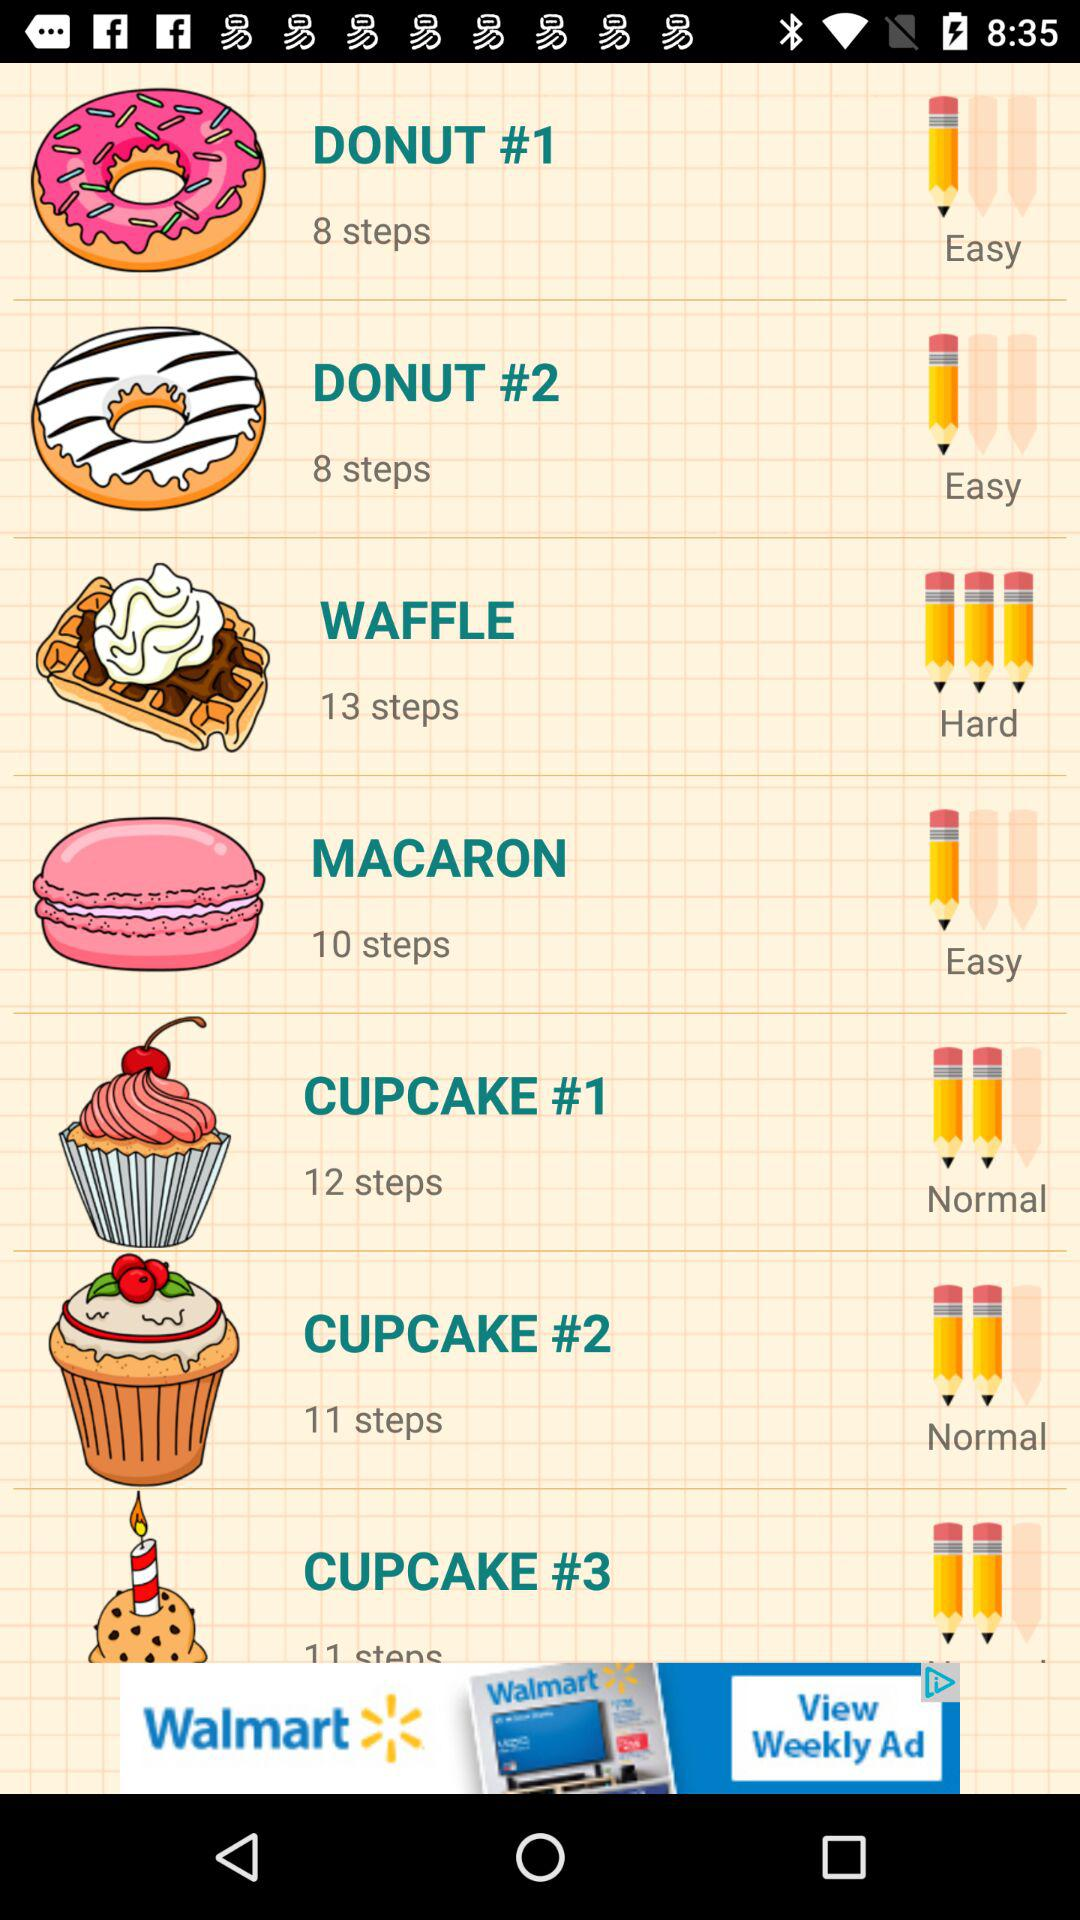How many steps are given to make the waffle? There are 13 steps given to make the waffle. 